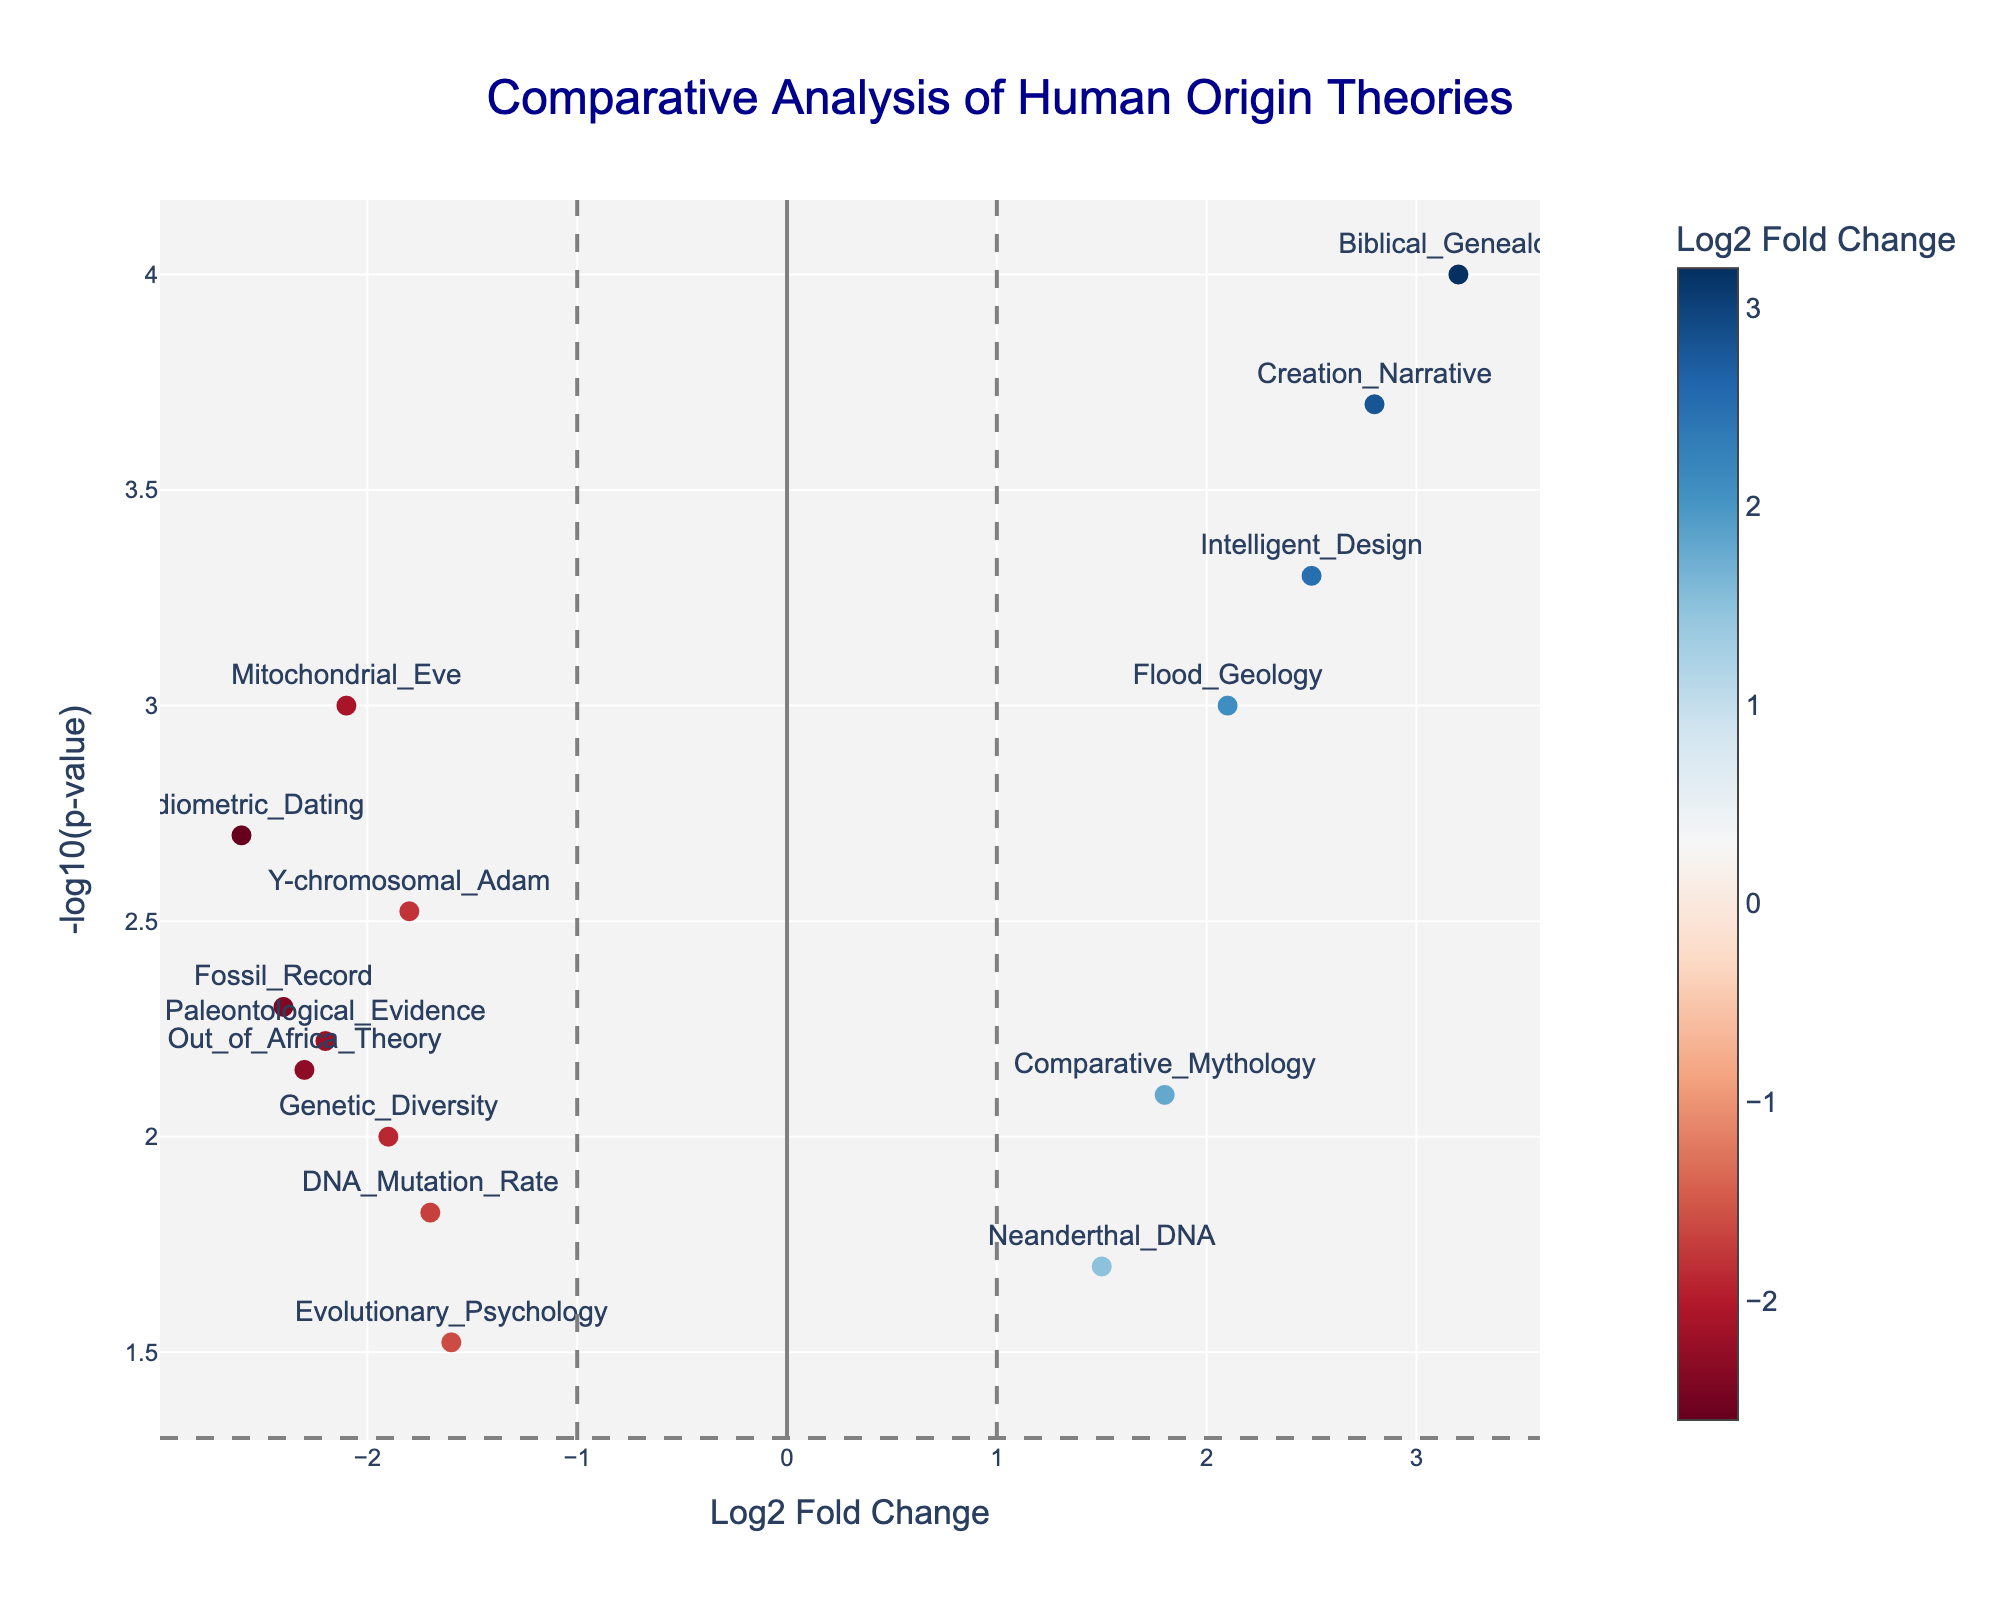What does the title of the figure indicate? The title "Comparative Analysis of Human Origin Theories" suggests that the figure compares different theories or explanations of human origins using a volcano plot.
Answer: Comparative Analysis of Human Origin Theories How many data points are there in the plot? The plot includes 15 different data points representing various theories or explanations of human origins. Each data point is shown as a marker on the plot.
Answer: 15 Which explanations have the highest and lowest -log10(p-value)? To identify the highest and lowest -log10(p-value), examine the vertical axis. The highest point represents the lowest p-value, and the lowest point represents the highest p-value. According to the plot, "Biblical Genealogy" has the highest -log10(p-value), and "Evolutionary Psychology" has the lowest -log10(p-value).
Answer: Biblical Genealogy, Evolutionary Psychology What is the Log2 Fold Change for "Mitochondrial Eve"? Locate "Mitochondrial Eve" on the plot and find its x-axis position, which gives the Log2 Fold Change. It is placed at -2.1 on the x-axis.
Answer: -2.1 Which data points fall within the significance threshold lines for both Log2 Fold Change and p-value?<br /> The significance thresholds are indicated by vertical lines at Log2 Fold Change values of -1 and 1, and a horizontal line at p-value = 0.05 (-log10(p-value) = 1.301). Data points within these thresholds are those whose x-axis value is between -1 and 1, and whose y-axis value is above 1.301. Based on the figure, the data points "Evolutionary Psychology" and "Neanderthal DNA" fall within these significance thresholds.
Answer: Evolutionary Psychology, Neanderthal DNA Compare the significance (p-value) of "Creation Narrative" and "Flood Geology". Which is more significant? To compare the significance, look at the -log10(p-value) of these two points. The higher the -log10(p-value), the more significant the result. "Creation Narrative" has a -log10(p-value) of about 3.698, while "Flood Geology" has a -log10(p-value) of about 3.000. Therefore, "Creation Narrative" is more significant.
Answer: Creation Narrative What is the average Log2 Fold Change for the points that represent low p-values (high significance)? Identifying points with -log10(p-value) higher than a significant threshold (e.g., 1.301), the points are "Radiometric Dating," "Biblical Genealogy," "Creation Narrative," "Intelligent Design," "Flood Geology," and "Mitochondrial Eve." Calculate the average of their Log2 Fold Change values: (-2.1) + (-2.6) + 3.2 + 2.5 + 2.1 + (-2.4) = 0.7/6 ≈ 0.12.
Answer: 0.12 